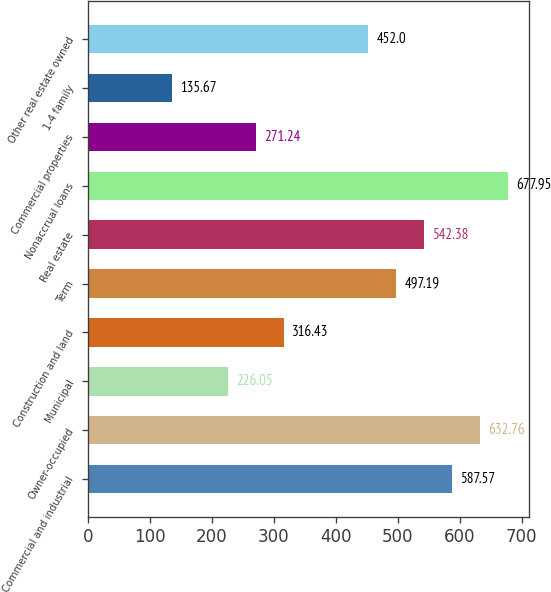Convert chart to OTSL. <chart><loc_0><loc_0><loc_500><loc_500><bar_chart><fcel>Commercial and industrial<fcel>Owner-occupied<fcel>Municipal<fcel>Construction and land<fcel>Term<fcel>Real estate<fcel>Nonaccrual loans<fcel>Commercial properties<fcel>1-4 family<fcel>Other real estate owned<nl><fcel>587.57<fcel>632.76<fcel>226.05<fcel>316.43<fcel>497.19<fcel>542.38<fcel>677.95<fcel>271.24<fcel>135.67<fcel>452<nl></chart> 